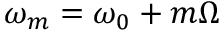Convert formula to latex. <formula><loc_0><loc_0><loc_500><loc_500>\omega _ { m } = \omega _ { 0 } + m \Omega</formula> 